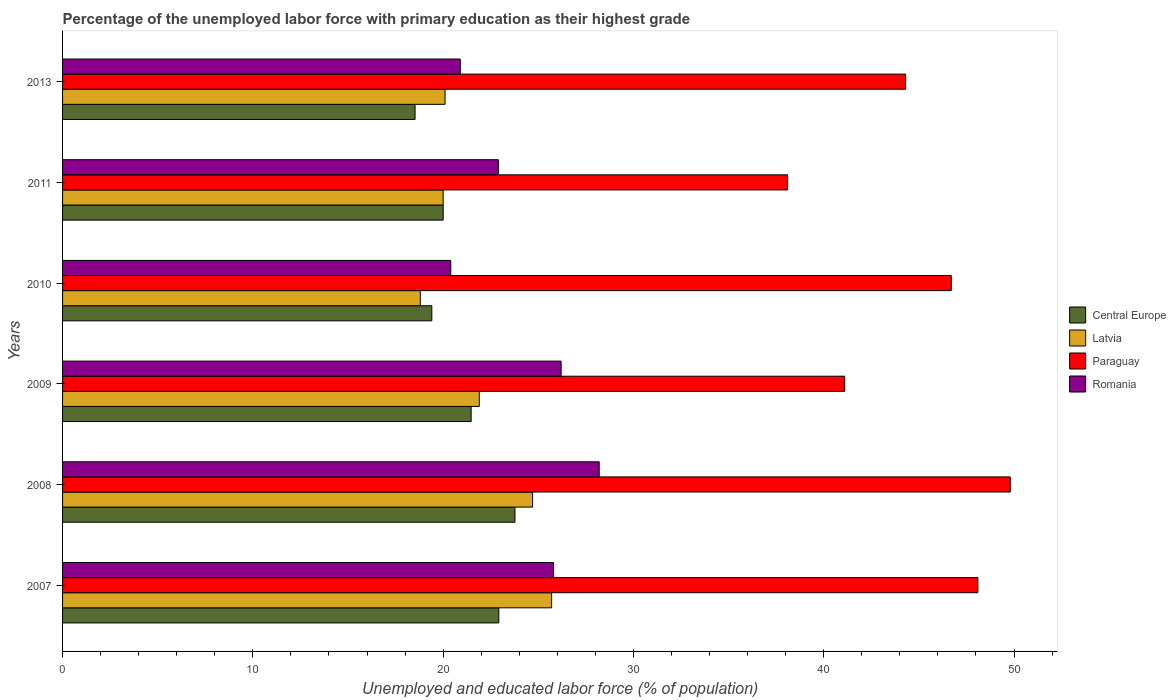How many bars are there on the 6th tick from the top?
Keep it short and to the point. 4. In how many cases, is the number of bars for a given year not equal to the number of legend labels?
Ensure brevity in your answer.  0. What is the percentage of the unemployed labor force with primary education in Paraguay in 2008?
Make the answer very short. 49.8. Across all years, what is the maximum percentage of the unemployed labor force with primary education in Paraguay?
Offer a very short reply. 49.8. Across all years, what is the minimum percentage of the unemployed labor force with primary education in Paraguay?
Provide a succinct answer. 38.1. In which year was the percentage of the unemployed labor force with primary education in Central Europe maximum?
Make the answer very short. 2008. What is the total percentage of the unemployed labor force with primary education in Romania in the graph?
Provide a succinct answer. 144.4. What is the difference between the percentage of the unemployed labor force with primary education in Latvia in 2010 and that in 2013?
Offer a very short reply. -1.3. What is the difference between the percentage of the unemployed labor force with primary education in Central Europe in 2009 and the percentage of the unemployed labor force with primary education in Romania in 2007?
Your answer should be compact. -4.33. What is the average percentage of the unemployed labor force with primary education in Latvia per year?
Your answer should be compact. 21.87. In the year 2009, what is the difference between the percentage of the unemployed labor force with primary education in Paraguay and percentage of the unemployed labor force with primary education in Romania?
Offer a very short reply. 14.9. What is the ratio of the percentage of the unemployed labor force with primary education in Paraguay in 2009 to that in 2013?
Provide a succinct answer. 0.93. What is the difference between the highest and the second highest percentage of the unemployed labor force with primary education in Central Europe?
Provide a short and direct response. 0.85. What is the difference between the highest and the lowest percentage of the unemployed labor force with primary education in Paraguay?
Offer a terse response. 11.7. In how many years, is the percentage of the unemployed labor force with primary education in Latvia greater than the average percentage of the unemployed labor force with primary education in Latvia taken over all years?
Offer a terse response. 3. Is the sum of the percentage of the unemployed labor force with primary education in Central Europe in 2009 and 2011 greater than the maximum percentage of the unemployed labor force with primary education in Latvia across all years?
Your answer should be very brief. Yes. Is it the case that in every year, the sum of the percentage of the unemployed labor force with primary education in Central Europe and percentage of the unemployed labor force with primary education in Paraguay is greater than the sum of percentage of the unemployed labor force with primary education in Latvia and percentage of the unemployed labor force with primary education in Romania?
Your answer should be compact. Yes. What does the 4th bar from the top in 2007 represents?
Provide a succinct answer. Central Europe. What does the 3rd bar from the bottom in 2007 represents?
Make the answer very short. Paraguay. How many years are there in the graph?
Your response must be concise. 6. Does the graph contain any zero values?
Keep it short and to the point. No. Does the graph contain grids?
Offer a very short reply. No. How many legend labels are there?
Make the answer very short. 4. What is the title of the graph?
Make the answer very short. Percentage of the unemployed labor force with primary education as their highest grade. Does "Northern Mariana Islands" appear as one of the legend labels in the graph?
Your response must be concise. No. What is the label or title of the X-axis?
Keep it short and to the point. Unemployed and educated labor force (% of population). What is the label or title of the Y-axis?
Give a very brief answer. Years. What is the Unemployed and educated labor force (% of population) of Central Europe in 2007?
Your response must be concise. 22.93. What is the Unemployed and educated labor force (% of population) of Latvia in 2007?
Provide a short and direct response. 25.7. What is the Unemployed and educated labor force (% of population) of Paraguay in 2007?
Ensure brevity in your answer.  48.1. What is the Unemployed and educated labor force (% of population) in Romania in 2007?
Your answer should be very brief. 25.8. What is the Unemployed and educated labor force (% of population) in Central Europe in 2008?
Your response must be concise. 23.77. What is the Unemployed and educated labor force (% of population) in Latvia in 2008?
Provide a succinct answer. 24.7. What is the Unemployed and educated labor force (% of population) in Paraguay in 2008?
Ensure brevity in your answer.  49.8. What is the Unemployed and educated labor force (% of population) in Romania in 2008?
Give a very brief answer. 28.2. What is the Unemployed and educated labor force (% of population) of Central Europe in 2009?
Provide a short and direct response. 21.47. What is the Unemployed and educated labor force (% of population) in Latvia in 2009?
Your answer should be very brief. 21.9. What is the Unemployed and educated labor force (% of population) in Paraguay in 2009?
Ensure brevity in your answer.  41.1. What is the Unemployed and educated labor force (% of population) in Romania in 2009?
Ensure brevity in your answer.  26.2. What is the Unemployed and educated labor force (% of population) of Central Europe in 2010?
Make the answer very short. 19.41. What is the Unemployed and educated labor force (% of population) in Latvia in 2010?
Provide a short and direct response. 18.8. What is the Unemployed and educated labor force (% of population) in Paraguay in 2010?
Your answer should be very brief. 46.7. What is the Unemployed and educated labor force (% of population) of Romania in 2010?
Provide a succinct answer. 20.4. What is the Unemployed and educated labor force (% of population) in Central Europe in 2011?
Offer a terse response. 20. What is the Unemployed and educated labor force (% of population) in Latvia in 2011?
Your answer should be very brief. 20. What is the Unemployed and educated labor force (% of population) in Paraguay in 2011?
Provide a succinct answer. 38.1. What is the Unemployed and educated labor force (% of population) in Romania in 2011?
Offer a very short reply. 22.9. What is the Unemployed and educated labor force (% of population) of Central Europe in 2013?
Your answer should be compact. 18.52. What is the Unemployed and educated labor force (% of population) of Latvia in 2013?
Your response must be concise. 20.1. What is the Unemployed and educated labor force (% of population) in Paraguay in 2013?
Keep it short and to the point. 44.3. What is the Unemployed and educated labor force (% of population) in Romania in 2013?
Offer a very short reply. 20.9. Across all years, what is the maximum Unemployed and educated labor force (% of population) of Central Europe?
Give a very brief answer. 23.77. Across all years, what is the maximum Unemployed and educated labor force (% of population) of Latvia?
Ensure brevity in your answer.  25.7. Across all years, what is the maximum Unemployed and educated labor force (% of population) in Paraguay?
Provide a succinct answer. 49.8. Across all years, what is the maximum Unemployed and educated labor force (% of population) in Romania?
Your answer should be compact. 28.2. Across all years, what is the minimum Unemployed and educated labor force (% of population) of Central Europe?
Provide a succinct answer. 18.52. Across all years, what is the minimum Unemployed and educated labor force (% of population) in Latvia?
Provide a succinct answer. 18.8. Across all years, what is the minimum Unemployed and educated labor force (% of population) in Paraguay?
Make the answer very short. 38.1. Across all years, what is the minimum Unemployed and educated labor force (% of population) of Romania?
Provide a succinct answer. 20.4. What is the total Unemployed and educated labor force (% of population) of Central Europe in the graph?
Ensure brevity in your answer.  126.1. What is the total Unemployed and educated labor force (% of population) in Latvia in the graph?
Your response must be concise. 131.2. What is the total Unemployed and educated labor force (% of population) of Paraguay in the graph?
Provide a succinct answer. 268.1. What is the total Unemployed and educated labor force (% of population) in Romania in the graph?
Provide a short and direct response. 144.4. What is the difference between the Unemployed and educated labor force (% of population) in Central Europe in 2007 and that in 2008?
Your answer should be compact. -0.85. What is the difference between the Unemployed and educated labor force (% of population) in Latvia in 2007 and that in 2008?
Keep it short and to the point. 1. What is the difference between the Unemployed and educated labor force (% of population) of Paraguay in 2007 and that in 2008?
Ensure brevity in your answer.  -1.7. What is the difference between the Unemployed and educated labor force (% of population) in Central Europe in 2007 and that in 2009?
Provide a short and direct response. 1.45. What is the difference between the Unemployed and educated labor force (% of population) of Romania in 2007 and that in 2009?
Make the answer very short. -0.4. What is the difference between the Unemployed and educated labor force (% of population) in Central Europe in 2007 and that in 2010?
Offer a terse response. 3.52. What is the difference between the Unemployed and educated labor force (% of population) in Latvia in 2007 and that in 2010?
Offer a very short reply. 6.9. What is the difference between the Unemployed and educated labor force (% of population) of Paraguay in 2007 and that in 2010?
Your answer should be very brief. 1.4. What is the difference between the Unemployed and educated labor force (% of population) of Central Europe in 2007 and that in 2011?
Offer a very short reply. 2.92. What is the difference between the Unemployed and educated labor force (% of population) of Central Europe in 2007 and that in 2013?
Make the answer very short. 4.4. What is the difference between the Unemployed and educated labor force (% of population) of Latvia in 2007 and that in 2013?
Provide a succinct answer. 5.6. What is the difference between the Unemployed and educated labor force (% of population) in Paraguay in 2007 and that in 2013?
Give a very brief answer. 3.8. What is the difference between the Unemployed and educated labor force (% of population) of Romania in 2007 and that in 2013?
Your answer should be compact. 4.9. What is the difference between the Unemployed and educated labor force (% of population) of Central Europe in 2008 and that in 2009?
Your answer should be very brief. 2.3. What is the difference between the Unemployed and educated labor force (% of population) of Romania in 2008 and that in 2009?
Offer a very short reply. 2. What is the difference between the Unemployed and educated labor force (% of population) of Central Europe in 2008 and that in 2010?
Offer a terse response. 4.37. What is the difference between the Unemployed and educated labor force (% of population) of Latvia in 2008 and that in 2010?
Your response must be concise. 5.9. What is the difference between the Unemployed and educated labor force (% of population) in Paraguay in 2008 and that in 2010?
Keep it short and to the point. 3.1. What is the difference between the Unemployed and educated labor force (% of population) in Romania in 2008 and that in 2010?
Keep it short and to the point. 7.8. What is the difference between the Unemployed and educated labor force (% of population) of Central Europe in 2008 and that in 2011?
Your answer should be very brief. 3.77. What is the difference between the Unemployed and educated labor force (% of population) in Latvia in 2008 and that in 2011?
Your answer should be very brief. 4.7. What is the difference between the Unemployed and educated labor force (% of population) of Paraguay in 2008 and that in 2011?
Offer a very short reply. 11.7. What is the difference between the Unemployed and educated labor force (% of population) in Romania in 2008 and that in 2011?
Offer a very short reply. 5.3. What is the difference between the Unemployed and educated labor force (% of population) of Central Europe in 2008 and that in 2013?
Your response must be concise. 5.25. What is the difference between the Unemployed and educated labor force (% of population) in Latvia in 2008 and that in 2013?
Provide a succinct answer. 4.6. What is the difference between the Unemployed and educated labor force (% of population) of Paraguay in 2008 and that in 2013?
Ensure brevity in your answer.  5.5. What is the difference between the Unemployed and educated labor force (% of population) of Central Europe in 2009 and that in 2010?
Provide a short and direct response. 2.07. What is the difference between the Unemployed and educated labor force (% of population) of Latvia in 2009 and that in 2010?
Offer a very short reply. 3.1. What is the difference between the Unemployed and educated labor force (% of population) in Romania in 2009 and that in 2010?
Ensure brevity in your answer.  5.8. What is the difference between the Unemployed and educated labor force (% of population) in Central Europe in 2009 and that in 2011?
Provide a succinct answer. 1.47. What is the difference between the Unemployed and educated labor force (% of population) in Paraguay in 2009 and that in 2011?
Your answer should be very brief. 3. What is the difference between the Unemployed and educated labor force (% of population) of Romania in 2009 and that in 2011?
Offer a very short reply. 3.3. What is the difference between the Unemployed and educated labor force (% of population) of Central Europe in 2009 and that in 2013?
Make the answer very short. 2.95. What is the difference between the Unemployed and educated labor force (% of population) in Latvia in 2009 and that in 2013?
Give a very brief answer. 1.8. What is the difference between the Unemployed and educated labor force (% of population) in Romania in 2009 and that in 2013?
Offer a terse response. 5.3. What is the difference between the Unemployed and educated labor force (% of population) of Central Europe in 2010 and that in 2011?
Provide a succinct answer. -0.6. What is the difference between the Unemployed and educated labor force (% of population) in Paraguay in 2010 and that in 2011?
Your answer should be compact. 8.6. What is the difference between the Unemployed and educated labor force (% of population) in Central Europe in 2010 and that in 2013?
Your response must be concise. 0.88. What is the difference between the Unemployed and educated labor force (% of population) of Romania in 2010 and that in 2013?
Offer a very short reply. -0.5. What is the difference between the Unemployed and educated labor force (% of population) in Central Europe in 2011 and that in 2013?
Your answer should be very brief. 1.48. What is the difference between the Unemployed and educated labor force (% of population) of Latvia in 2011 and that in 2013?
Keep it short and to the point. -0.1. What is the difference between the Unemployed and educated labor force (% of population) in Central Europe in 2007 and the Unemployed and educated labor force (% of population) in Latvia in 2008?
Your response must be concise. -1.77. What is the difference between the Unemployed and educated labor force (% of population) of Central Europe in 2007 and the Unemployed and educated labor force (% of population) of Paraguay in 2008?
Offer a very short reply. -26.87. What is the difference between the Unemployed and educated labor force (% of population) in Central Europe in 2007 and the Unemployed and educated labor force (% of population) in Romania in 2008?
Give a very brief answer. -5.27. What is the difference between the Unemployed and educated labor force (% of population) in Latvia in 2007 and the Unemployed and educated labor force (% of population) in Paraguay in 2008?
Provide a succinct answer. -24.1. What is the difference between the Unemployed and educated labor force (% of population) of Latvia in 2007 and the Unemployed and educated labor force (% of population) of Romania in 2008?
Keep it short and to the point. -2.5. What is the difference between the Unemployed and educated labor force (% of population) in Central Europe in 2007 and the Unemployed and educated labor force (% of population) in Latvia in 2009?
Ensure brevity in your answer.  1.03. What is the difference between the Unemployed and educated labor force (% of population) in Central Europe in 2007 and the Unemployed and educated labor force (% of population) in Paraguay in 2009?
Keep it short and to the point. -18.17. What is the difference between the Unemployed and educated labor force (% of population) of Central Europe in 2007 and the Unemployed and educated labor force (% of population) of Romania in 2009?
Provide a succinct answer. -3.27. What is the difference between the Unemployed and educated labor force (% of population) of Latvia in 2007 and the Unemployed and educated labor force (% of population) of Paraguay in 2009?
Give a very brief answer. -15.4. What is the difference between the Unemployed and educated labor force (% of population) in Paraguay in 2007 and the Unemployed and educated labor force (% of population) in Romania in 2009?
Give a very brief answer. 21.9. What is the difference between the Unemployed and educated labor force (% of population) of Central Europe in 2007 and the Unemployed and educated labor force (% of population) of Latvia in 2010?
Ensure brevity in your answer.  4.13. What is the difference between the Unemployed and educated labor force (% of population) of Central Europe in 2007 and the Unemployed and educated labor force (% of population) of Paraguay in 2010?
Provide a short and direct response. -23.77. What is the difference between the Unemployed and educated labor force (% of population) of Central Europe in 2007 and the Unemployed and educated labor force (% of population) of Romania in 2010?
Offer a very short reply. 2.53. What is the difference between the Unemployed and educated labor force (% of population) in Latvia in 2007 and the Unemployed and educated labor force (% of population) in Paraguay in 2010?
Offer a terse response. -21. What is the difference between the Unemployed and educated labor force (% of population) of Paraguay in 2007 and the Unemployed and educated labor force (% of population) of Romania in 2010?
Give a very brief answer. 27.7. What is the difference between the Unemployed and educated labor force (% of population) in Central Europe in 2007 and the Unemployed and educated labor force (% of population) in Latvia in 2011?
Provide a succinct answer. 2.93. What is the difference between the Unemployed and educated labor force (% of population) of Central Europe in 2007 and the Unemployed and educated labor force (% of population) of Paraguay in 2011?
Provide a short and direct response. -15.17. What is the difference between the Unemployed and educated labor force (% of population) of Central Europe in 2007 and the Unemployed and educated labor force (% of population) of Romania in 2011?
Provide a succinct answer. 0.03. What is the difference between the Unemployed and educated labor force (% of population) of Latvia in 2007 and the Unemployed and educated labor force (% of population) of Paraguay in 2011?
Provide a short and direct response. -12.4. What is the difference between the Unemployed and educated labor force (% of population) in Paraguay in 2007 and the Unemployed and educated labor force (% of population) in Romania in 2011?
Your answer should be very brief. 25.2. What is the difference between the Unemployed and educated labor force (% of population) in Central Europe in 2007 and the Unemployed and educated labor force (% of population) in Latvia in 2013?
Ensure brevity in your answer.  2.83. What is the difference between the Unemployed and educated labor force (% of population) in Central Europe in 2007 and the Unemployed and educated labor force (% of population) in Paraguay in 2013?
Provide a short and direct response. -21.37. What is the difference between the Unemployed and educated labor force (% of population) of Central Europe in 2007 and the Unemployed and educated labor force (% of population) of Romania in 2013?
Provide a short and direct response. 2.03. What is the difference between the Unemployed and educated labor force (% of population) of Latvia in 2007 and the Unemployed and educated labor force (% of population) of Paraguay in 2013?
Make the answer very short. -18.6. What is the difference between the Unemployed and educated labor force (% of population) of Latvia in 2007 and the Unemployed and educated labor force (% of population) of Romania in 2013?
Ensure brevity in your answer.  4.8. What is the difference between the Unemployed and educated labor force (% of population) of Paraguay in 2007 and the Unemployed and educated labor force (% of population) of Romania in 2013?
Keep it short and to the point. 27.2. What is the difference between the Unemployed and educated labor force (% of population) in Central Europe in 2008 and the Unemployed and educated labor force (% of population) in Latvia in 2009?
Give a very brief answer. 1.87. What is the difference between the Unemployed and educated labor force (% of population) of Central Europe in 2008 and the Unemployed and educated labor force (% of population) of Paraguay in 2009?
Give a very brief answer. -17.33. What is the difference between the Unemployed and educated labor force (% of population) in Central Europe in 2008 and the Unemployed and educated labor force (% of population) in Romania in 2009?
Ensure brevity in your answer.  -2.43. What is the difference between the Unemployed and educated labor force (% of population) in Latvia in 2008 and the Unemployed and educated labor force (% of population) in Paraguay in 2009?
Your answer should be compact. -16.4. What is the difference between the Unemployed and educated labor force (% of population) in Paraguay in 2008 and the Unemployed and educated labor force (% of population) in Romania in 2009?
Provide a short and direct response. 23.6. What is the difference between the Unemployed and educated labor force (% of population) in Central Europe in 2008 and the Unemployed and educated labor force (% of population) in Latvia in 2010?
Your response must be concise. 4.97. What is the difference between the Unemployed and educated labor force (% of population) of Central Europe in 2008 and the Unemployed and educated labor force (% of population) of Paraguay in 2010?
Keep it short and to the point. -22.93. What is the difference between the Unemployed and educated labor force (% of population) of Central Europe in 2008 and the Unemployed and educated labor force (% of population) of Romania in 2010?
Provide a succinct answer. 3.37. What is the difference between the Unemployed and educated labor force (% of population) of Latvia in 2008 and the Unemployed and educated labor force (% of population) of Romania in 2010?
Make the answer very short. 4.3. What is the difference between the Unemployed and educated labor force (% of population) of Paraguay in 2008 and the Unemployed and educated labor force (% of population) of Romania in 2010?
Your response must be concise. 29.4. What is the difference between the Unemployed and educated labor force (% of population) of Central Europe in 2008 and the Unemployed and educated labor force (% of population) of Latvia in 2011?
Your response must be concise. 3.77. What is the difference between the Unemployed and educated labor force (% of population) in Central Europe in 2008 and the Unemployed and educated labor force (% of population) in Paraguay in 2011?
Give a very brief answer. -14.33. What is the difference between the Unemployed and educated labor force (% of population) in Central Europe in 2008 and the Unemployed and educated labor force (% of population) in Romania in 2011?
Ensure brevity in your answer.  0.87. What is the difference between the Unemployed and educated labor force (% of population) in Latvia in 2008 and the Unemployed and educated labor force (% of population) in Paraguay in 2011?
Your response must be concise. -13.4. What is the difference between the Unemployed and educated labor force (% of population) of Latvia in 2008 and the Unemployed and educated labor force (% of population) of Romania in 2011?
Provide a short and direct response. 1.8. What is the difference between the Unemployed and educated labor force (% of population) in Paraguay in 2008 and the Unemployed and educated labor force (% of population) in Romania in 2011?
Offer a terse response. 26.9. What is the difference between the Unemployed and educated labor force (% of population) in Central Europe in 2008 and the Unemployed and educated labor force (% of population) in Latvia in 2013?
Your answer should be compact. 3.67. What is the difference between the Unemployed and educated labor force (% of population) of Central Europe in 2008 and the Unemployed and educated labor force (% of population) of Paraguay in 2013?
Give a very brief answer. -20.53. What is the difference between the Unemployed and educated labor force (% of population) in Central Europe in 2008 and the Unemployed and educated labor force (% of population) in Romania in 2013?
Your answer should be compact. 2.87. What is the difference between the Unemployed and educated labor force (% of population) of Latvia in 2008 and the Unemployed and educated labor force (% of population) of Paraguay in 2013?
Ensure brevity in your answer.  -19.6. What is the difference between the Unemployed and educated labor force (% of population) of Latvia in 2008 and the Unemployed and educated labor force (% of population) of Romania in 2013?
Offer a terse response. 3.8. What is the difference between the Unemployed and educated labor force (% of population) of Paraguay in 2008 and the Unemployed and educated labor force (% of population) of Romania in 2013?
Your answer should be compact. 28.9. What is the difference between the Unemployed and educated labor force (% of population) of Central Europe in 2009 and the Unemployed and educated labor force (% of population) of Latvia in 2010?
Offer a very short reply. 2.67. What is the difference between the Unemployed and educated labor force (% of population) of Central Europe in 2009 and the Unemployed and educated labor force (% of population) of Paraguay in 2010?
Your answer should be compact. -25.23. What is the difference between the Unemployed and educated labor force (% of population) in Central Europe in 2009 and the Unemployed and educated labor force (% of population) in Romania in 2010?
Provide a succinct answer. 1.07. What is the difference between the Unemployed and educated labor force (% of population) of Latvia in 2009 and the Unemployed and educated labor force (% of population) of Paraguay in 2010?
Your answer should be very brief. -24.8. What is the difference between the Unemployed and educated labor force (% of population) in Latvia in 2009 and the Unemployed and educated labor force (% of population) in Romania in 2010?
Offer a terse response. 1.5. What is the difference between the Unemployed and educated labor force (% of population) in Paraguay in 2009 and the Unemployed and educated labor force (% of population) in Romania in 2010?
Offer a terse response. 20.7. What is the difference between the Unemployed and educated labor force (% of population) in Central Europe in 2009 and the Unemployed and educated labor force (% of population) in Latvia in 2011?
Your answer should be compact. 1.47. What is the difference between the Unemployed and educated labor force (% of population) of Central Europe in 2009 and the Unemployed and educated labor force (% of population) of Paraguay in 2011?
Keep it short and to the point. -16.63. What is the difference between the Unemployed and educated labor force (% of population) of Central Europe in 2009 and the Unemployed and educated labor force (% of population) of Romania in 2011?
Give a very brief answer. -1.43. What is the difference between the Unemployed and educated labor force (% of population) in Latvia in 2009 and the Unemployed and educated labor force (% of population) in Paraguay in 2011?
Ensure brevity in your answer.  -16.2. What is the difference between the Unemployed and educated labor force (% of population) in Latvia in 2009 and the Unemployed and educated labor force (% of population) in Romania in 2011?
Offer a terse response. -1. What is the difference between the Unemployed and educated labor force (% of population) in Paraguay in 2009 and the Unemployed and educated labor force (% of population) in Romania in 2011?
Offer a very short reply. 18.2. What is the difference between the Unemployed and educated labor force (% of population) in Central Europe in 2009 and the Unemployed and educated labor force (% of population) in Latvia in 2013?
Your answer should be very brief. 1.37. What is the difference between the Unemployed and educated labor force (% of population) of Central Europe in 2009 and the Unemployed and educated labor force (% of population) of Paraguay in 2013?
Your answer should be compact. -22.83. What is the difference between the Unemployed and educated labor force (% of population) in Central Europe in 2009 and the Unemployed and educated labor force (% of population) in Romania in 2013?
Keep it short and to the point. 0.57. What is the difference between the Unemployed and educated labor force (% of population) in Latvia in 2009 and the Unemployed and educated labor force (% of population) in Paraguay in 2013?
Your answer should be compact. -22.4. What is the difference between the Unemployed and educated labor force (% of population) in Latvia in 2009 and the Unemployed and educated labor force (% of population) in Romania in 2013?
Offer a very short reply. 1. What is the difference between the Unemployed and educated labor force (% of population) in Paraguay in 2009 and the Unemployed and educated labor force (% of population) in Romania in 2013?
Keep it short and to the point. 20.2. What is the difference between the Unemployed and educated labor force (% of population) in Central Europe in 2010 and the Unemployed and educated labor force (% of population) in Latvia in 2011?
Give a very brief answer. -0.59. What is the difference between the Unemployed and educated labor force (% of population) in Central Europe in 2010 and the Unemployed and educated labor force (% of population) in Paraguay in 2011?
Provide a succinct answer. -18.7. What is the difference between the Unemployed and educated labor force (% of population) in Central Europe in 2010 and the Unemployed and educated labor force (% of population) in Romania in 2011?
Give a very brief answer. -3.5. What is the difference between the Unemployed and educated labor force (% of population) of Latvia in 2010 and the Unemployed and educated labor force (% of population) of Paraguay in 2011?
Offer a terse response. -19.3. What is the difference between the Unemployed and educated labor force (% of population) in Latvia in 2010 and the Unemployed and educated labor force (% of population) in Romania in 2011?
Make the answer very short. -4.1. What is the difference between the Unemployed and educated labor force (% of population) in Paraguay in 2010 and the Unemployed and educated labor force (% of population) in Romania in 2011?
Make the answer very short. 23.8. What is the difference between the Unemployed and educated labor force (% of population) of Central Europe in 2010 and the Unemployed and educated labor force (% of population) of Latvia in 2013?
Ensure brevity in your answer.  -0.69. What is the difference between the Unemployed and educated labor force (% of population) in Central Europe in 2010 and the Unemployed and educated labor force (% of population) in Paraguay in 2013?
Offer a terse response. -24.89. What is the difference between the Unemployed and educated labor force (% of population) of Central Europe in 2010 and the Unemployed and educated labor force (% of population) of Romania in 2013?
Keep it short and to the point. -1.5. What is the difference between the Unemployed and educated labor force (% of population) in Latvia in 2010 and the Unemployed and educated labor force (% of population) in Paraguay in 2013?
Your response must be concise. -25.5. What is the difference between the Unemployed and educated labor force (% of population) in Paraguay in 2010 and the Unemployed and educated labor force (% of population) in Romania in 2013?
Ensure brevity in your answer.  25.8. What is the difference between the Unemployed and educated labor force (% of population) in Central Europe in 2011 and the Unemployed and educated labor force (% of population) in Latvia in 2013?
Make the answer very short. -0.1. What is the difference between the Unemployed and educated labor force (% of population) in Central Europe in 2011 and the Unemployed and educated labor force (% of population) in Paraguay in 2013?
Keep it short and to the point. -24.3. What is the difference between the Unemployed and educated labor force (% of population) of Central Europe in 2011 and the Unemployed and educated labor force (% of population) of Romania in 2013?
Your answer should be compact. -0.9. What is the difference between the Unemployed and educated labor force (% of population) of Latvia in 2011 and the Unemployed and educated labor force (% of population) of Paraguay in 2013?
Your response must be concise. -24.3. What is the difference between the Unemployed and educated labor force (% of population) of Paraguay in 2011 and the Unemployed and educated labor force (% of population) of Romania in 2013?
Provide a succinct answer. 17.2. What is the average Unemployed and educated labor force (% of population) of Central Europe per year?
Offer a very short reply. 21.02. What is the average Unemployed and educated labor force (% of population) in Latvia per year?
Ensure brevity in your answer.  21.87. What is the average Unemployed and educated labor force (% of population) of Paraguay per year?
Provide a succinct answer. 44.68. What is the average Unemployed and educated labor force (% of population) of Romania per year?
Provide a short and direct response. 24.07. In the year 2007, what is the difference between the Unemployed and educated labor force (% of population) in Central Europe and Unemployed and educated labor force (% of population) in Latvia?
Make the answer very short. -2.77. In the year 2007, what is the difference between the Unemployed and educated labor force (% of population) in Central Europe and Unemployed and educated labor force (% of population) in Paraguay?
Provide a short and direct response. -25.17. In the year 2007, what is the difference between the Unemployed and educated labor force (% of population) in Central Europe and Unemployed and educated labor force (% of population) in Romania?
Your answer should be compact. -2.87. In the year 2007, what is the difference between the Unemployed and educated labor force (% of population) of Latvia and Unemployed and educated labor force (% of population) of Paraguay?
Provide a succinct answer. -22.4. In the year 2007, what is the difference between the Unemployed and educated labor force (% of population) in Paraguay and Unemployed and educated labor force (% of population) in Romania?
Offer a terse response. 22.3. In the year 2008, what is the difference between the Unemployed and educated labor force (% of population) in Central Europe and Unemployed and educated labor force (% of population) in Latvia?
Give a very brief answer. -0.93. In the year 2008, what is the difference between the Unemployed and educated labor force (% of population) in Central Europe and Unemployed and educated labor force (% of population) in Paraguay?
Provide a succinct answer. -26.03. In the year 2008, what is the difference between the Unemployed and educated labor force (% of population) of Central Europe and Unemployed and educated labor force (% of population) of Romania?
Offer a terse response. -4.43. In the year 2008, what is the difference between the Unemployed and educated labor force (% of population) in Latvia and Unemployed and educated labor force (% of population) in Paraguay?
Keep it short and to the point. -25.1. In the year 2008, what is the difference between the Unemployed and educated labor force (% of population) in Latvia and Unemployed and educated labor force (% of population) in Romania?
Offer a very short reply. -3.5. In the year 2008, what is the difference between the Unemployed and educated labor force (% of population) of Paraguay and Unemployed and educated labor force (% of population) of Romania?
Your answer should be very brief. 21.6. In the year 2009, what is the difference between the Unemployed and educated labor force (% of population) in Central Europe and Unemployed and educated labor force (% of population) in Latvia?
Provide a short and direct response. -0.43. In the year 2009, what is the difference between the Unemployed and educated labor force (% of population) of Central Europe and Unemployed and educated labor force (% of population) of Paraguay?
Keep it short and to the point. -19.63. In the year 2009, what is the difference between the Unemployed and educated labor force (% of population) of Central Europe and Unemployed and educated labor force (% of population) of Romania?
Offer a very short reply. -4.73. In the year 2009, what is the difference between the Unemployed and educated labor force (% of population) in Latvia and Unemployed and educated labor force (% of population) in Paraguay?
Your answer should be very brief. -19.2. In the year 2009, what is the difference between the Unemployed and educated labor force (% of population) in Paraguay and Unemployed and educated labor force (% of population) in Romania?
Ensure brevity in your answer.  14.9. In the year 2010, what is the difference between the Unemployed and educated labor force (% of population) of Central Europe and Unemployed and educated labor force (% of population) of Latvia?
Keep it short and to the point. 0.6. In the year 2010, what is the difference between the Unemployed and educated labor force (% of population) of Central Europe and Unemployed and educated labor force (% of population) of Paraguay?
Your answer should be very brief. -27.3. In the year 2010, what is the difference between the Unemployed and educated labor force (% of population) in Central Europe and Unemployed and educated labor force (% of population) in Romania?
Keep it short and to the point. -0.99. In the year 2010, what is the difference between the Unemployed and educated labor force (% of population) in Latvia and Unemployed and educated labor force (% of population) in Paraguay?
Ensure brevity in your answer.  -27.9. In the year 2010, what is the difference between the Unemployed and educated labor force (% of population) in Paraguay and Unemployed and educated labor force (% of population) in Romania?
Offer a terse response. 26.3. In the year 2011, what is the difference between the Unemployed and educated labor force (% of population) of Central Europe and Unemployed and educated labor force (% of population) of Latvia?
Provide a succinct answer. 0. In the year 2011, what is the difference between the Unemployed and educated labor force (% of population) of Central Europe and Unemployed and educated labor force (% of population) of Paraguay?
Provide a succinct answer. -18.1. In the year 2011, what is the difference between the Unemployed and educated labor force (% of population) in Central Europe and Unemployed and educated labor force (% of population) in Romania?
Give a very brief answer. -2.9. In the year 2011, what is the difference between the Unemployed and educated labor force (% of population) of Latvia and Unemployed and educated labor force (% of population) of Paraguay?
Your answer should be compact. -18.1. In the year 2011, what is the difference between the Unemployed and educated labor force (% of population) in Latvia and Unemployed and educated labor force (% of population) in Romania?
Your response must be concise. -2.9. In the year 2013, what is the difference between the Unemployed and educated labor force (% of population) in Central Europe and Unemployed and educated labor force (% of population) in Latvia?
Ensure brevity in your answer.  -1.58. In the year 2013, what is the difference between the Unemployed and educated labor force (% of population) in Central Europe and Unemployed and educated labor force (% of population) in Paraguay?
Your answer should be very brief. -25.78. In the year 2013, what is the difference between the Unemployed and educated labor force (% of population) in Central Europe and Unemployed and educated labor force (% of population) in Romania?
Offer a very short reply. -2.38. In the year 2013, what is the difference between the Unemployed and educated labor force (% of population) of Latvia and Unemployed and educated labor force (% of population) of Paraguay?
Offer a very short reply. -24.2. In the year 2013, what is the difference between the Unemployed and educated labor force (% of population) in Paraguay and Unemployed and educated labor force (% of population) in Romania?
Provide a succinct answer. 23.4. What is the ratio of the Unemployed and educated labor force (% of population) of Central Europe in 2007 to that in 2008?
Offer a very short reply. 0.96. What is the ratio of the Unemployed and educated labor force (% of population) of Latvia in 2007 to that in 2008?
Provide a short and direct response. 1.04. What is the ratio of the Unemployed and educated labor force (% of population) in Paraguay in 2007 to that in 2008?
Offer a terse response. 0.97. What is the ratio of the Unemployed and educated labor force (% of population) of Romania in 2007 to that in 2008?
Your answer should be compact. 0.91. What is the ratio of the Unemployed and educated labor force (% of population) in Central Europe in 2007 to that in 2009?
Ensure brevity in your answer.  1.07. What is the ratio of the Unemployed and educated labor force (% of population) in Latvia in 2007 to that in 2009?
Make the answer very short. 1.17. What is the ratio of the Unemployed and educated labor force (% of population) in Paraguay in 2007 to that in 2009?
Offer a very short reply. 1.17. What is the ratio of the Unemployed and educated labor force (% of population) of Romania in 2007 to that in 2009?
Offer a very short reply. 0.98. What is the ratio of the Unemployed and educated labor force (% of population) of Central Europe in 2007 to that in 2010?
Your response must be concise. 1.18. What is the ratio of the Unemployed and educated labor force (% of population) of Latvia in 2007 to that in 2010?
Provide a short and direct response. 1.37. What is the ratio of the Unemployed and educated labor force (% of population) in Romania in 2007 to that in 2010?
Your answer should be very brief. 1.26. What is the ratio of the Unemployed and educated labor force (% of population) in Central Europe in 2007 to that in 2011?
Provide a short and direct response. 1.15. What is the ratio of the Unemployed and educated labor force (% of population) of Latvia in 2007 to that in 2011?
Your answer should be very brief. 1.28. What is the ratio of the Unemployed and educated labor force (% of population) of Paraguay in 2007 to that in 2011?
Ensure brevity in your answer.  1.26. What is the ratio of the Unemployed and educated labor force (% of population) in Romania in 2007 to that in 2011?
Your answer should be very brief. 1.13. What is the ratio of the Unemployed and educated labor force (% of population) of Central Europe in 2007 to that in 2013?
Ensure brevity in your answer.  1.24. What is the ratio of the Unemployed and educated labor force (% of population) in Latvia in 2007 to that in 2013?
Offer a very short reply. 1.28. What is the ratio of the Unemployed and educated labor force (% of population) in Paraguay in 2007 to that in 2013?
Give a very brief answer. 1.09. What is the ratio of the Unemployed and educated labor force (% of population) of Romania in 2007 to that in 2013?
Offer a very short reply. 1.23. What is the ratio of the Unemployed and educated labor force (% of population) of Central Europe in 2008 to that in 2009?
Provide a short and direct response. 1.11. What is the ratio of the Unemployed and educated labor force (% of population) in Latvia in 2008 to that in 2009?
Provide a short and direct response. 1.13. What is the ratio of the Unemployed and educated labor force (% of population) in Paraguay in 2008 to that in 2009?
Make the answer very short. 1.21. What is the ratio of the Unemployed and educated labor force (% of population) of Romania in 2008 to that in 2009?
Offer a terse response. 1.08. What is the ratio of the Unemployed and educated labor force (% of population) in Central Europe in 2008 to that in 2010?
Ensure brevity in your answer.  1.23. What is the ratio of the Unemployed and educated labor force (% of population) in Latvia in 2008 to that in 2010?
Provide a succinct answer. 1.31. What is the ratio of the Unemployed and educated labor force (% of population) of Paraguay in 2008 to that in 2010?
Ensure brevity in your answer.  1.07. What is the ratio of the Unemployed and educated labor force (% of population) in Romania in 2008 to that in 2010?
Give a very brief answer. 1.38. What is the ratio of the Unemployed and educated labor force (% of population) of Central Europe in 2008 to that in 2011?
Provide a short and direct response. 1.19. What is the ratio of the Unemployed and educated labor force (% of population) in Latvia in 2008 to that in 2011?
Keep it short and to the point. 1.24. What is the ratio of the Unemployed and educated labor force (% of population) in Paraguay in 2008 to that in 2011?
Your response must be concise. 1.31. What is the ratio of the Unemployed and educated labor force (% of population) in Romania in 2008 to that in 2011?
Ensure brevity in your answer.  1.23. What is the ratio of the Unemployed and educated labor force (% of population) of Central Europe in 2008 to that in 2013?
Your response must be concise. 1.28. What is the ratio of the Unemployed and educated labor force (% of population) in Latvia in 2008 to that in 2013?
Give a very brief answer. 1.23. What is the ratio of the Unemployed and educated labor force (% of population) in Paraguay in 2008 to that in 2013?
Ensure brevity in your answer.  1.12. What is the ratio of the Unemployed and educated labor force (% of population) of Romania in 2008 to that in 2013?
Your answer should be compact. 1.35. What is the ratio of the Unemployed and educated labor force (% of population) of Central Europe in 2009 to that in 2010?
Ensure brevity in your answer.  1.11. What is the ratio of the Unemployed and educated labor force (% of population) of Latvia in 2009 to that in 2010?
Keep it short and to the point. 1.16. What is the ratio of the Unemployed and educated labor force (% of population) in Paraguay in 2009 to that in 2010?
Give a very brief answer. 0.88. What is the ratio of the Unemployed and educated labor force (% of population) in Romania in 2009 to that in 2010?
Keep it short and to the point. 1.28. What is the ratio of the Unemployed and educated labor force (% of population) of Central Europe in 2009 to that in 2011?
Your answer should be very brief. 1.07. What is the ratio of the Unemployed and educated labor force (% of population) of Latvia in 2009 to that in 2011?
Provide a succinct answer. 1.09. What is the ratio of the Unemployed and educated labor force (% of population) of Paraguay in 2009 to that in 2011?
Your answer should be very brief. 1.08. What is the ratio of the Unemployed and educated labor force (% of population) of Romania in 2009 to that in 2011?
Make the answer very short. 1.14. What is the ratio of the Unemployed and educated labor force (% of population) of Central Europe in 2009 to that in 2013?
Your response must be concise. 1.16. What is the ratio of the Unemployed and educated labor force (% of population) of Latvia in 2009 to that in 2013?
Give a very brief answer. 1.09. What is the ratio of the Unemployed and educated labor force (% of population) in Paraguay in 2009 to that in 2013?
Make the answer very short. 0.93. What is the ratio of the Unemployed and educated labor force (% of population) of Romania in 2009 to that in 2013?
Make the answer very short. 1.25. What is the ratio of the Unemployed and educated labor force (% of population) of Central Europe in 2010 to that in 2011?
Your answer should be very brief. 0.97. What is the ratio of the Unemployed and educated labor force (% of population) of Latvia in 2010 to that in 2011?
Your answer should be compact. 0.94. What is the ratio of the Unemployed and educated labor force (% of population) of Paraguay in 2010 to that in 2011?
Ensure brevity in your answer.  1.23. What is the ratio of the Unemployed and educated labor force (% of population) of Romania in 2010 to that in 2011?
Offer a very short reply. 0.89. What is the ratio of the Unemployed and educated labor force (% of population) in Central Europe in 2010 to that in 2013?
Your answer should be very brief. 1.05. What is the ratio of the Unemployed and educated labor force (% of population) in Latvia in 2010 to that in 2013?
Your response must be concise. 0.94. What is the ratio of the Unemployed and educated labor force (% of population) in Paraguay in 2010 to that in 2013?
Offer a very short reply. 1.05. What is the ratio of the Unemployed and educated labor force (% of population) in Romania in 2010 to that in 2013?
Your response must be concise. 0.98. What is the ratio of the Unemployed and educated labor force (% of population) of Central Europe in 2011 to that in 2013?
Your response must be concise. 1.08. What is the ratio of the Unemployed and educated labor force (% of population) in Latvia in 2011 to that in 2013?
Offer a terse response. 0.99. What is the ratio of the Unemployed and educated labor force (% of population) of Paraguay in 2011 to that in 2013?
Your answer should be compact. 0.86. What is the ratio of the Unemployed and educated labor force (% of population) in Romania in 2011 to that in 2013?
Offer a very short reply. 1.1. What is the difference between the highest and the second highest Unemployed and educated labor force (% of population) of Central Europe?
Your answer should be very brief. 0.85. What is the difference between the highest and the second highest Unemployed and educated labor force (% of population) in Latvia?
Offer a terse response. 1. What is the difference between the highest and the second highest Unemployed and educated labor force (% of population) in Paraguay?
Keep it short and to the point. 1.7. What is the difference between the highest and the second highest Unemployed and educated labor force (% of population) of Romania?
Ensure brevity in your answer.  2. What is the difference between the highest and the lowest Unemployed and educated labor force (% of population) in Central Europe?
Give a very brief answer. 5.25. What is the difference between the highest and the lowest Unemployed and educated labor force (% of population) in Latvia?
Ensure brevity in your answer.  6.9. What is the difference between the highest and the lowest Unemployed and educated labor force (% of population) of Paraguay?
Your answer should be compact. 11.7. What is the difference between the highest and the lowest Unemployed and educated labor force (% of population) in Romania?
Provide a short and direct response. 7.8. 